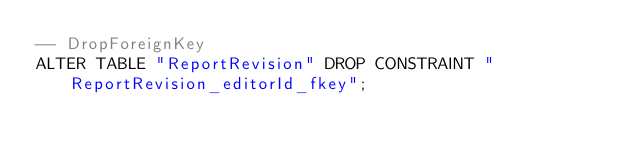Convert code to text. <code><loc_0><loc_0><loc_500><loc_500><_SQL_>-- DropForeignKey
ALTER TABLE "ReportRevision" DROP CONSTRAINT "ReportRevision_editorId_fkey";
</code> 